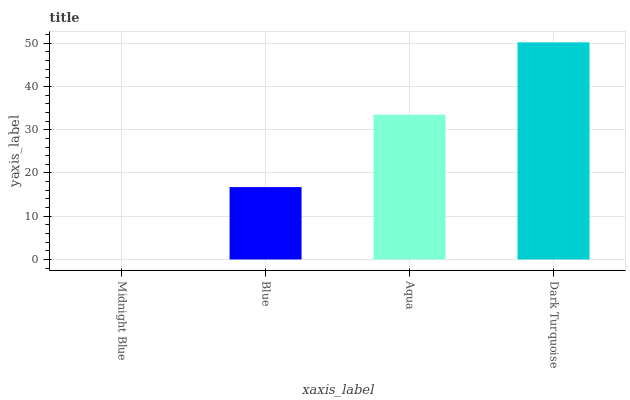Is Midnight Blue the minimum?
Answer yes or no. Yes. Is Dark Turquoise the maximum?
Answer yes or no. Yes. Is Blue the minimum?
Answer yes or no. No. Is Blue the maximum?
Answer yes or no. No. Is Blue greater than Midnight Blue?
Answer yes or no. Yes. Is Midnight Blue less than Blue?
Answer yes or no. Yes. Is Midnight Blue greater than Blue?
Answer yes or no. No. Is Blue less than Midnight Blue?
Answer yes or no. No. Is Aqua the high median?
Answer yes or no. Yes. Is Blue the low median?
Answer yes or no. Yes. Is Midnight Blue the high median?
Answer yes or no. No. Is Aqua the low median?
Answer yes or no. No. 